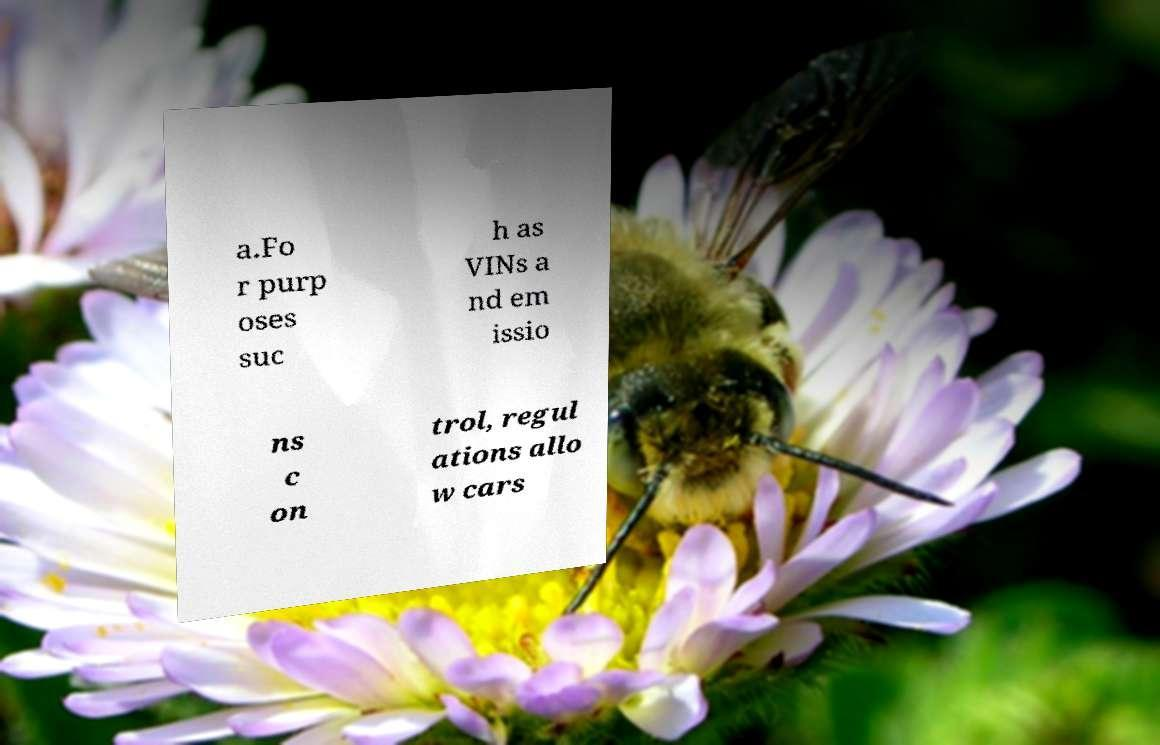Could you assist in decoding the text presented in this image and type it out clearly? a.Fo r purp oses suc h as VINs a nd em issio ns c on trol, regul ations allo w cars 